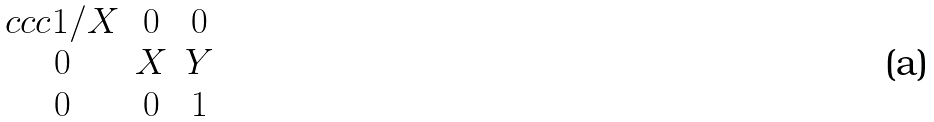<formula> <loc_0><loc_0><loc_500><loc_500>\begin{matrix} { c c c } 1 / X & 0 & 0 \\ 0 & X & Y \\ 0 & 0 & 1 \end{matrix}</formula> 